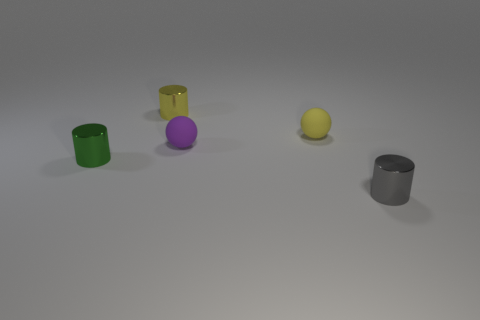How would you describe the arrangement of the objects in the image? The objects in the image are arranged linearly across the horizontal axis, with varied spaces between them. Starting from the left, there is a green cylinder, a gold cylinder, a purple sphere, a yellow sphere, and finally a matte grey cylinder. What can you tell me about the lighting in this image? The lighting in the image is soft and uniform, suggesting a diffuse light source overhead. There are subtle shadows visible beneath each object, indicating a light source positioned above and slightly to the front of the objects. 